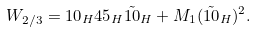<formula> <loc_0><loc_0><loc_500><loc_500>W _ { 2 / 3 } = { 1 0 } _ { H } { 4 5 } _ { H } \tilde { 1 0 } _ { H } + M _ { 1 } ( \tilde { 1 0 } _ { H } ) ^ { 2 } . \\</formula> 